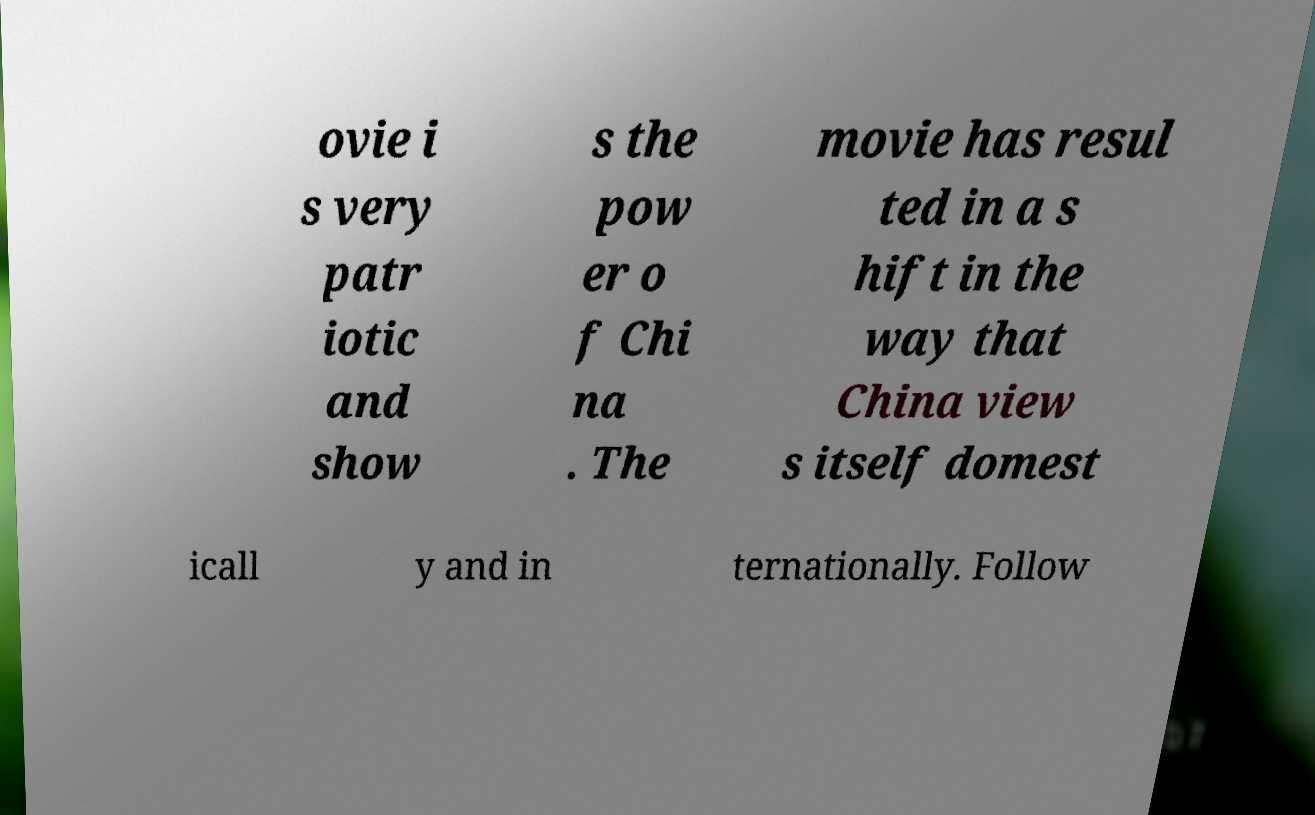Please identify and transcribe the text found in this image. ovie i s very patr iotic and show s the pow er o f Chi na . The movie has resul ted in a s hift in the way that China view s itself domest icall y and in ternationally. Follow 